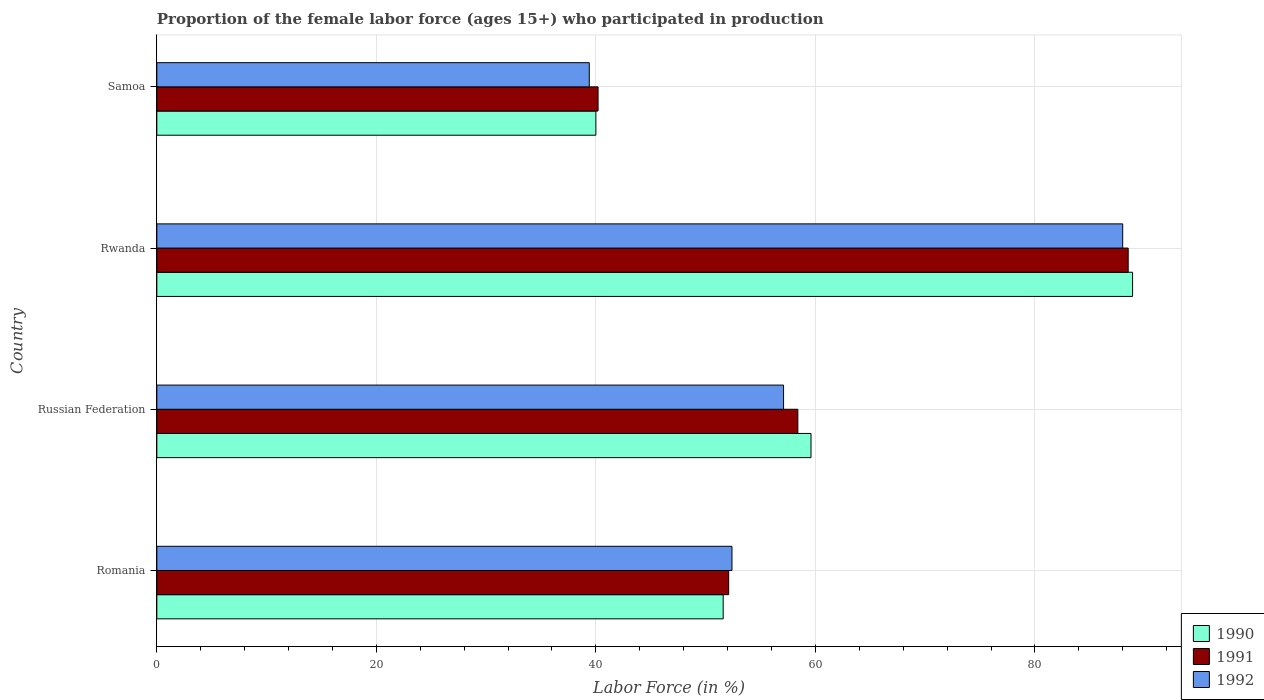Are the number of bars per tick equal to the number of legend labels?
Provide a short and direct response. Yes. How many bars are there on the 2nd tick from the top?
Your answer should be very brief. 3. What is the label of the 3rd group of bars from the top?
Ensure brevity in your answer.  Russian Federation. Across all countries, what is the maximum proportion of the female labor force who participated in production in 1992?
Provide a short and direct response. 88. Across all countries, what is the minimum proportion of the female labor force who participated in production in 1990?
Your answer should be compact. 40. In which country was the proportion of the female labor force who participated in production in 1990 maximum?
Offer a very short reply. Rwanda. In which country was the proportion of the female labor force who participated in production in 1992 minimum?
Provide a succinct answer. Samoa. What is the total proportion of the female labor force who participated in production in 1990 in the graph?
Offer a very short reply. 240.1. What is the difference between the proportion of the female labor force who participated in production in 1992 in Russian Federation and the proportion of the female labor force who participated in production in 1990 in Samoa?
Your answer should be very brief. 17.1. What is the average proportion of the female labor force who participated in production in 1990 per country?
Offer a very short reply. 60.02. What is the difference between the proportion of the female labor force who participated in production in 1992 and proportion of the female labor force who participated in production in 1991 in Rwanda?
Provide a succinct answer. -0.5. In how many countries, is the proportion of the female labor force who participated in production in 1990 greater than 28 %?
Your answer should be very brief. 4. What is the ratio of the proportion of the female labor force who participated in production in 1992 in Russian Federation to that in Rwanda?
Give a very brief answer. 0.65. What is the difference between the highest and the second highest proportion of the female labor force who participated in production in 1991?
Your answer should be very brief. 30.1. What is the difference between the highest and the lowest proportion of the female labor force who participated in production in 1990?
Provide a short and direct response. 48.9. In how many countries, is the proportion of the female labor force who participated in production in 1992 greater than the average proportion of the female labor force who participated in production in 1992 taken over all countries?
Offer a very short reply. 1. What does the 1st bar from the top in Rwanda represents?
Your answer should be compact. 1992. What does the 2nd bar from the bottom in Samoa represents?
Make the answer very short. 1991. Are all the bars in the graph horizontal?
Ensure brevity in your answer.  Yes. What is the difference between two consecutive major ticks on the X-axis?
Ensure brevity in your answer.  20. Are the values on the major ticks of X-axis written in scientific E-notation?
Provide a short and direct response. No. Does the graph contain any zero values?
Ensure brevity in your answer.  No. Does the graph contain grids?
Ensure brevity in your answer.  Yes. Where does the legend appear in the graph?
Your answer should be very brief. Bottom right. How many legend labels are there?
Give a very brief answer. 3. What is the title of the graph?
Keep it short and to the point. Proportion of the female labor force (ages 15+) who participated in production. What is the label or title of the X-axis?
Provide a short and direct response. Labor Force (in %). What is the Labor Force (in %) in 1990 in Romania?
Make the answer very short. 51.6. What is the Labor Force (in %) of 1991 in Romania?
Make the answer very short. 52.1. What is the Labor Force (in %) in 1992 in Romania?
Provide a succinct answer. 52.4. What is the Labor Force (in %) of 1990 in Russian Federation?
Provide a short and direct response. 59.6. What is the Labor Force (in %) in 1991 in Russian Federation?
Keep it short and to the point. 58.4. What is the Labor Force (in %) in 1992 in Russian Federation?
Keep it short and to the point. 57.1. What is the Labor Force (in %) of 1990 in Rwanda?
Make the answer very short. 88.9. What is the Labor Force (in %) of 1991 in Rwanda?
Keep it short and to the point. 88.5. What is the Labor Force (in %) of 1992 in Rwanda?
Make the answer very short. 88. What is the Labor Force (in %) of 1990 in Samoa?
Make the answer very short. 40. What is the Labor Force (in %) of 1991 in Samoa?
Offer a very short reply. 40.2. What is the Labor Force (in %) of 1992 in Samoa?
Give a very brief answer. 39.4. Across all countries, what is the maximum Labor Force (in %) of 1990?
Your response must be concise. 88.9. Across all countries, what is the maximum Labor Force (in %) in 1991?
Make the answer very short. 88.5. Across all countries, what is the maximum Labor Force (in %) of 1992?
Ensure brevity in your answer.  88. Across all countries, what is the minimum Labor Force (in %) of 1990?
Provide a short and direct response. 40. Across all countries, what is the minimum Labor Force (in %) in 1991?
Your response must be concise. 40.2. Across all countries, what is the minimum Labor Force (in %) in 1992?
Give a very brief answer. 39.4. What is the total Labor Force (in %) in 1990 in the graph?
Make the answer very short. 240.1. What is the total Labor Force (in %) of 1991 in the graph?
Provide a succinct answer. 239.2. What is the total Labor Force (in %) in 1992 in the graph?
Provide a succinct answer. 236.9. What is the difference between the Labor Force (in %) of 1992 in Romania and that in Russian Federation?
Offer a very short reply. -4.7. What is the difference between the Labor Force (in %) of 1990 in Romania and that in Rwanda?
Provide a short and direct response. -37.3. What is the difference between the Labor Force (in %) in 1991 in Romania and that in Rwanda?
Provide a succinct answer. -36.4. What is the difference between the Labor Force (in %) of 1992 in Romania and that in Rwanda?
Keep it short and to the point. -35.6. What is the difference between the Labor Force (in %) in 1991 in Romania and that in Samoa?
Your response must be concise. 11.9. What is the difference between the Labor Force (in %) in 1990 in Russian Federation and that in Rwanda?
Your answer should be very brief. -29.3. What is the difference between the Labor Force (in %) of 1991 in Russian Federation and that in Rwanda?
Provide a short and direct response. -30.1. What is the difference between the Labor Force (in %) in 1992 in Russian Federation and that in Rwanda?
Offer a terse response. -30.9. What is the difference between the Labor Force (in %) of 1990 in Russian Federation and that in Samoa?
Your answer should be compact. 19.6. What is the difference between the Labor Force (in %) in 1991 in Russian Federation and that in Samoa?
Make the answer very short. 18.2. What is the difference between the Labor Force (in %) of 1990 in Rwanda and that in Samoa?
Offer a very short reply. 48.9. What is the difference between the Labor Force (in %) of 1991 in Rwanda and that in Samoa?
Keep it short and to the point. 48.3. What is the difference between the Labor Force (in %) in 1992 in Rwanda and that in Samoa?
Offer a terse response. 48.6. What is the difference between the Labor Force (in %) in 1990 in Romania and the Labor Force (in %) in 1991 in Russian Federation?
Offer a very short reply. -6.8. What is the difference between the Labor Force (in %) of 1990 in Romania and the Labor Force (in %) of 1992 in Russian Federation?
Provide a short and direct response. -5.5. What is the difference between the Labor Force (in %) of 1991 in Romania and the Labor Force (in %) of 1992 in Russian Federation?
Your response must be concise. -5. What is the difference between the Labor Force (in %) in 1990 in Romania and the Labor Force (in %) in 1991 in Rwanda?
Offer a very short reply. -36.9. What is the difference between the Labor Force (in %) in 1990 in Romania and the Labor Force (in %) in 1992 in Rwanda?
Offer a very short reply. -36.4. What is the difference between the Labor Force (in %) in 1991 in Romania and the Labor Force (in %) in 1992 in Rwanda?
Keep it short and to the point. -35.9. What is the difference between the Labor Force (in %) of 1990 in Russian Federation and the Labor Force (in %) of 1991 in Rwanda?
Offer a terse response. -28.9. What is the difference between the Labor Force (in %) in 1990 in Russian Federation and the Labor Force (in %) in 1992 in Rwanda?
Your answer should be compact. -28.4. What is the difference between the Labor Force (in %) of 1991 in Russian Federation and the Labor Force (in %) of 1992 in Rwanda?
Ensure brevity in your answer.  -29.6. What is the difference between the Labor Force (in %) of 1990 in Russian Federation and the Labor Force (in %) of 1991 in Samoa?
Your answer should be compact. 19.4. What is the difference between the Labor Force (in %) of 1990 in Russian Federation and the Labor Force (in %) of 1992 in Samoa?
Provide a short and direct response. 20.2. What is the difference between the Labor Force (in %) of 1991 in Russian Federation and the Labor Force (in %) of 1992 in Samoa?
Offer a terse response. 19. What is the difference between the Labor Force (in %) in 1990 in Rwanda and the Labor Force (in %) in 1991 in Samoa?
Provide a short and direct response. 48.7. What is the difference between the Labor Force (in %) of 1990 in Rwanda and the Labor Force (in %) of 1992 in Samoa?
Keep it short and to the point. 49.5. What is the difference between the Labor Force (in %) of 1991 in Rwanda and the Labor Force (in %) of 1992 in Samoa?
Provide a succinct answer. 49.1. What is the average Labor Force (in %) in 1990 per country?
Your answer should be very brief. 60.02. What is the average Labor Force (in %) in 1991 per country?
Make the answer very short. 59.8. What is the average Labor Force (in %) of 1992 per country?
Keep it short and to the point. 59.23. What is the difference between the Labor Force (in %) of 1991 and Labor Force (in %) of 1992 in Romania?
Make the answer very short. -0.3. What is the difference between the Labor Force (in %) in 1990 and Labor Force (in %) in 1991 in Russian Federation?
Provide a succinct answer. 1.2. What is the difference between the Labor Force (in %) in 1990 and Labor Force (in %) in 1992 in Russian Federation?
Provide a succinct answer. 2.5. What is the difference between the Labor Force (in %) in 1990 and Labor Force (in %) in 1991 in Rwanda?
Your answer should be compact. 0.4. What is the difference between the Labor Force (in %) in 1991 and Labor Force (in %) in 1992 in Rwanda?
Keep it short and to the point. 0.5. What is the difference between the Labor Force (in %) in 1991 and Labor Force (in %) in 1992 in Samoa?
Make the answer very short. 0.8. What is the ratio of the Labor Force (in %) in 1990 in Romania to that in Russian Federation?
Keep it short and to the point. 0.87. What is the ratio of the Labor Force (in %) of 1991 in Romania to that in Russian Federation?
Your answer should be very brief. 0.89. What is the ratio of the Labor Force (in %) of 1992 in Romania to that in Russian Federation?
Keep it short and to the point. 0.92. What is the ratio of the Labor Force (in %) of 1990 in Romania to that in Rwanda?
Give a very brief answer. 0.58. What is the ratio of the Labor Force (in %) in 1991 in Romania to that in Rwanda?
Keep it short and to the point. 0.59. What is the ratio of the Labor Force (in %) of 1992 in Romania to that in Rwanda?
Your answer should be compact. 0.6. What is the ratio of the Labor Force (in %) of 1990 in Romania to that in Samoa?
Keep it short and to the point. 1.29. What is the ratio of the Labor Force (in %) of 1991 in Romania to that in Samoa?
Offer a terse response. 1.3. What is the ratio of the Labor Force (in %) in 1992 in Romania to that in Samoa?
Your answer should be compact. 1.33. What is the ratio of the Labor Force (in %) of 1990 in Russian Federation to that in Rwanda?
Your response must be concise. 0.67. What is the ratio of the Labor Force (in %) of 1991 in Russian Federation to that in Rwanda?
Your answer should be very brief. 0.66. What is the ratio of the Labor Force (in %) in 1992 in Russian Federation to that in Rwanda?
Your response must be concise. 0.65. What is the ratio of the Labor Force (in %) in 1990 in Russian Federation to that in Samoa?
Provide a short and direct response. 1.49. What is the ratio of the Labor Force (in %) of 1991 in Russian Federation to that in Samoa?
Offer a very short reply. 1.45. What is the ratio of the Labor Force (in %) of 1992 in Russian Federation to that in Samoa?
Make the answer very short. 1.45. What is the ratio of the Labor Force (in %) of 1990 in Rwanda to that in Samoa?
Offer a very short reply. 2.22. What is the ratio of the Labor Force (in %) of 1991 in Rwanda to that in Samoa?
Give a very brief answer. 2.2. What is the ratio of the Labor Force (in %) of 1992 in Rwanda to that in Samoa?
Provide a short and direct response. 2.23. What is the difference between the highest and the second highest Labor Force (in %) of 1990?
Offer a terse response. 29.3. What is the difference between the highest and the second highest Labor Force (in %) in 1991?
Your response must be concise. 30.1. What is the difference between the highest and the second highest Labor Force (in %) in 1992?
Give a very brief answer. 30.9. What is the difference between the highest and the lowest Labor Force (in %) of 1990?
Your answer should be compact. 48.9. What is the difference between the highest and the lowest Labor Force (in %) of 1991?
Keep it short and to the point. 48.3. What is the difference between the highest and the lowest Labor Force (in %) of 1992?
Offer a terse response. 48.6. 